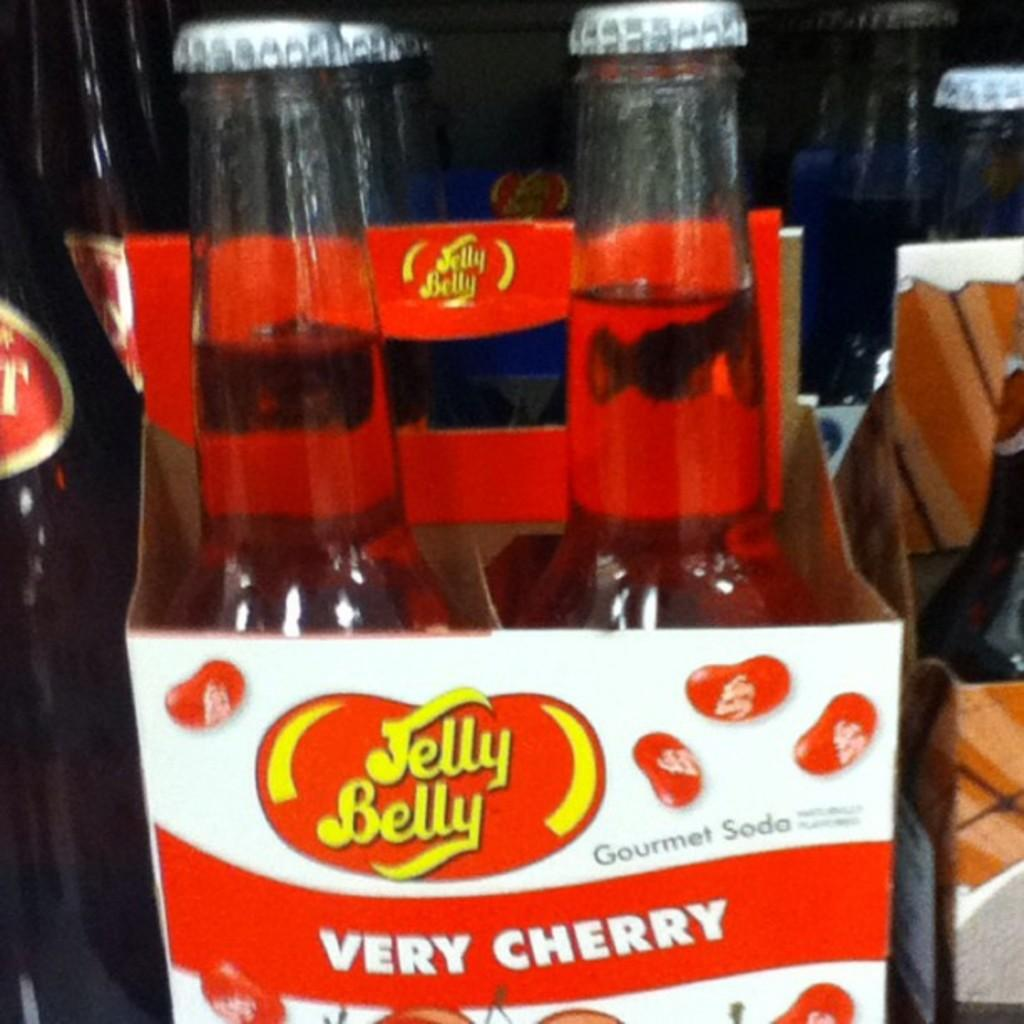What objects are present in the image? There are bottles in the image. Where are the bottles located? The bottles are on a box. Can you describe the box in the image? The box is white and red in color, and it has the words "very cherry" written on it. What type of shoes is your aunt wearing in the image? There is no mention of shoes or an aunt in the image, so it is not possible to answer that question. 